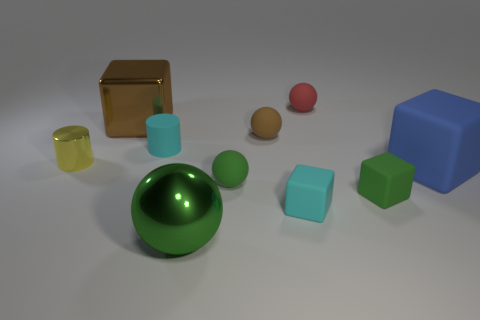Subtract all big matte blocks. How many blocks are left? 3 Subtract all brown spheres. How many spheres are left? 3 Subtract 1 blocks. How many blocks are left? 3 Subtract all blocks. How many objects are left? 6 Subtract all yellow cubes. How many cyan cylinders are left? 1 Add 8 green matte things. How many green matte things are left? 10 Add 1 blue objects. How many blue objects exist? 2 Subtract 0 red cubes. How many objects are left? 10 Subtract all gray balls. Subtract all gray cylinders. How many balls are left? 4 Subtract all yellow objects. Subtract all small green rubber things. How many objects are left? 7 